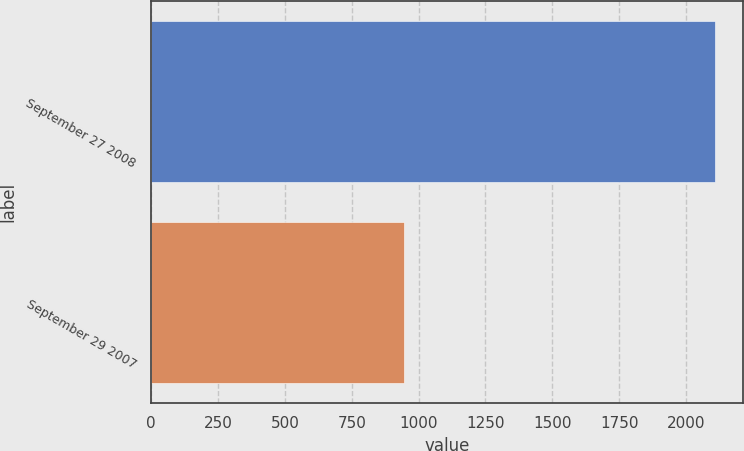Convert chart. <chart><loc_0><loc_0><loc_500><loc_500><bar_chart><fcel>September 27 2008<fcel>September 29 2007<nl><fcel>2109<fcel>947<nl></chart> 